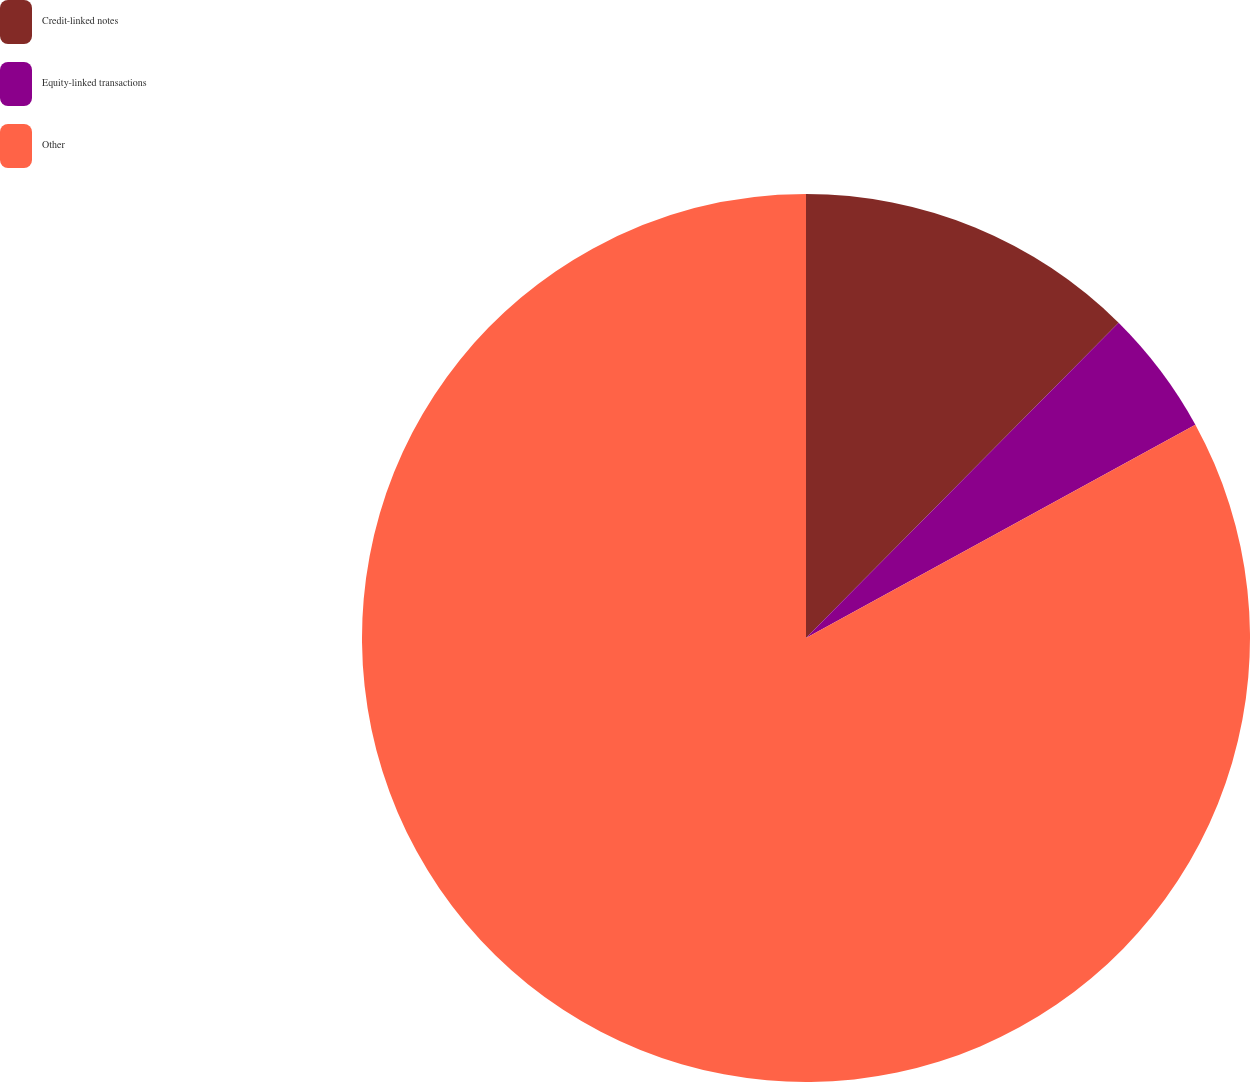<chart> <loc_0><loc_0><loc_500><loc_500><pie_chart><fcel>Credit-linked notes<fcel>Equity-linked transactions<fcel>Other<nl><fcel>12.43%<fcel>4.59%<fcel>82.97%<nl></chart> 